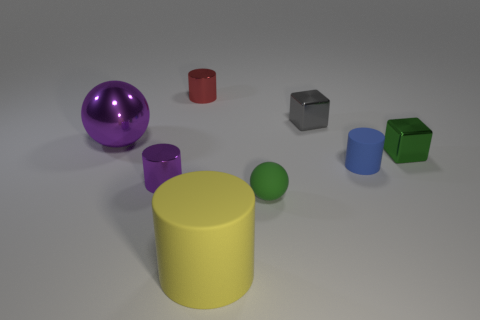Subtract 1 cylinders. How many cylinders are left? 3 Add 1 brown matte balls. How many objects exist? 9 Subtract all spheres. How many objects are left? 6 Subtract all rubber things. Subtract all tiny matte cylinders. How many objects are left? 4 Add 3 gray metallic blocks. How many gray metallic blocks are left? 4 Add 3 small green things. How many small green things exist? 5 Subtract 0 brown spheres. How many objects are left? 8 